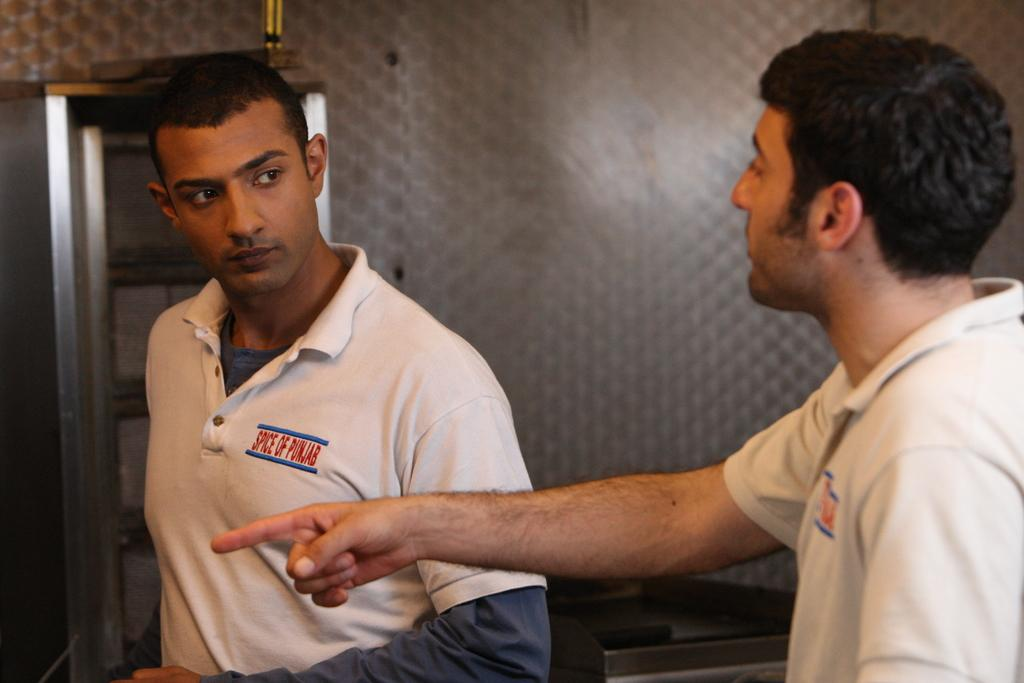How many people are in the image? There are two persons in the foreground of the image. What can be seen in the background of the image? There is a wall in the background of the image. What is located on the left side of the image? There is a rack on the left side of the image. What type of quill is being used by the person on the right side of the image? There is no quill present in the image; it features two persons in the foreground and a wall in the background. 